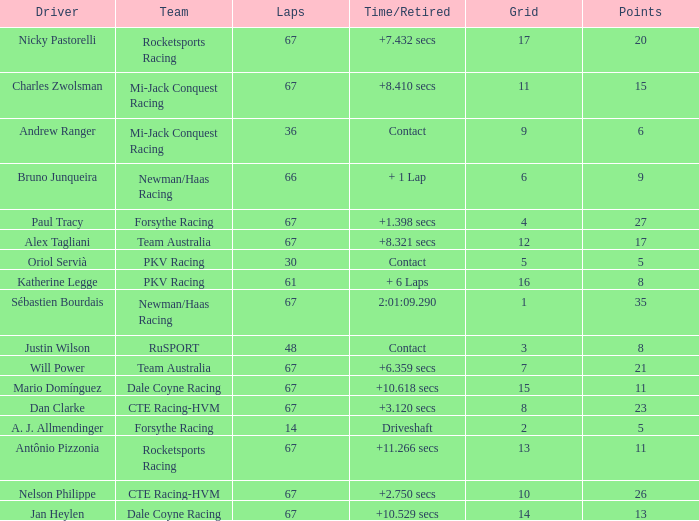What was time/retired with less than 67 laps and 6 points? Contact. 